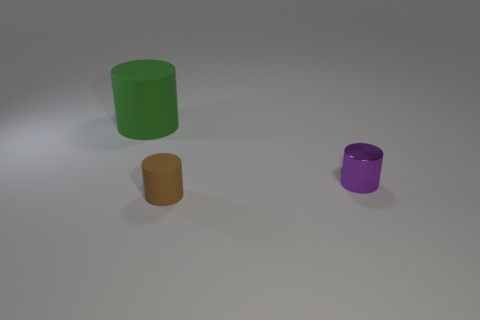How many purple objects have the same size as the green matte thing?
Offer a terse response. 0. The brown matte cylinder has what size?
Provide a short and direct response. Small. There is a tiny metal cylinder; how many green rubber cylinders are behind it?
Offer a terse response. 1. What is the shape of the small brown thing that is the same material as the large green cylinder?
Make the answer very short. Cylinder. Are there fewer tiny purple things in front of the tiny brown rubber cylinder than large rubber cylinders left of the small shiny thing?
Provide a short and direct response. Yes. Is the number of cylinders greater than the number of big cyan matte cubes?
Your answer should be very brief. Yes. What is the material of the tiny brown cylinder?
Provide a short and direct response. Rubber. The matte object that is in front of the small purple metallic cylinder is what color?
Your answer should be compact. Brown. Are there more small purple objects on the left side of the green thing than small cylinders behind the small brown rubber cylinder?
Provide a succinct answer. No. There is a object right of the object in front of the object on the right side of the brown thing; what is its size?
Make the answer very short. Small. 